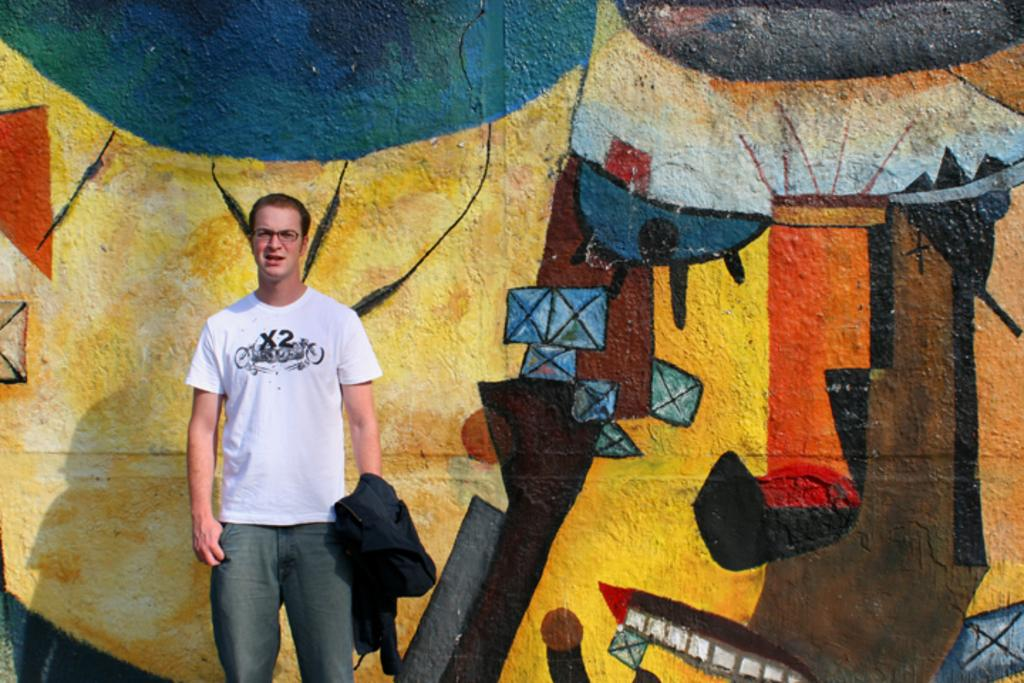What is the main subject of the image? There is a man standing in the image. What is the man holding in his hand? The man is carrying a jacket in his hand. What can be seen in the background of the image? There are paintings on the wall in the background of the image. What type of home can be seen in the image? There is no home visible in the image; it only shows a man standing with a jacket and paintings on the wall in the background. What does the market look like in the image? There is no market present in the image. 